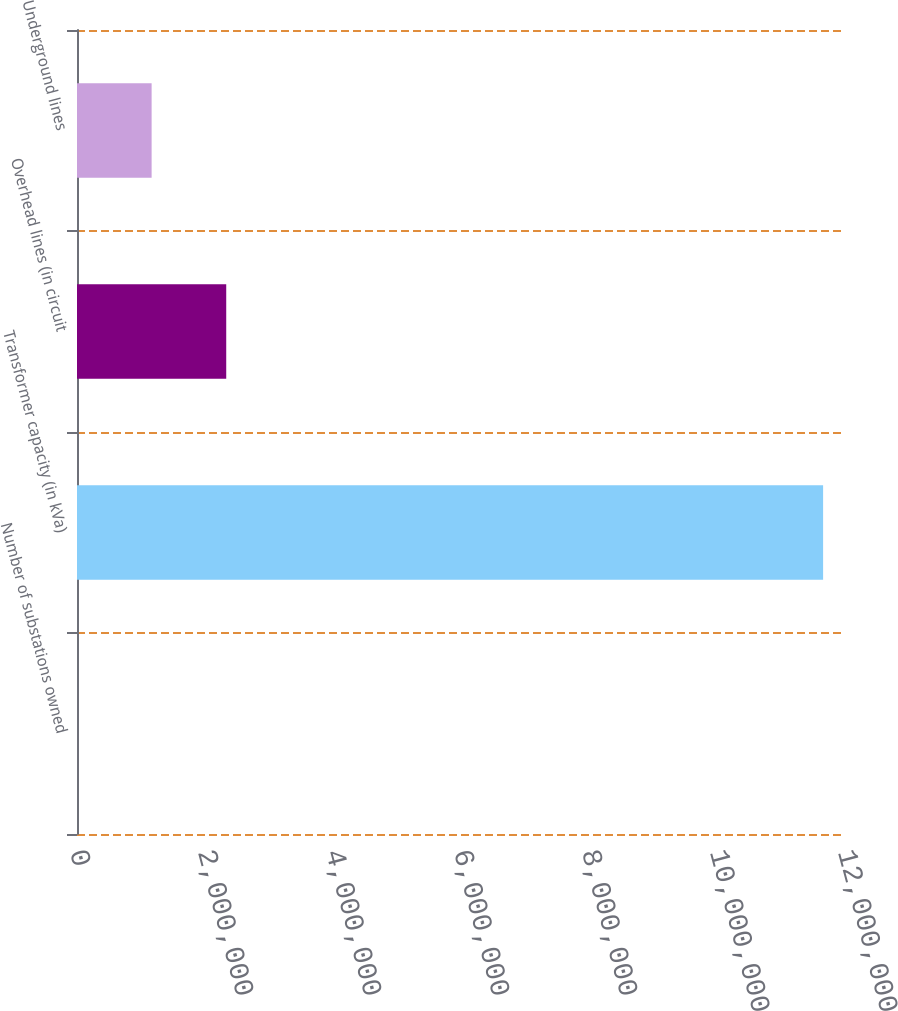<chart> <loc_0><loc_0><loc_500><loc_500><bar_chart><fcel>Number of substations owned<fcel>Transformer capacity (in kVa)<fcel>Overhead lines (in circuit<fcel>Underground lines<nl><fcel>134<fcel>1.1658e+07<fcel>2.33171e+06<fcel>1.16592e+06<nl></chart> 